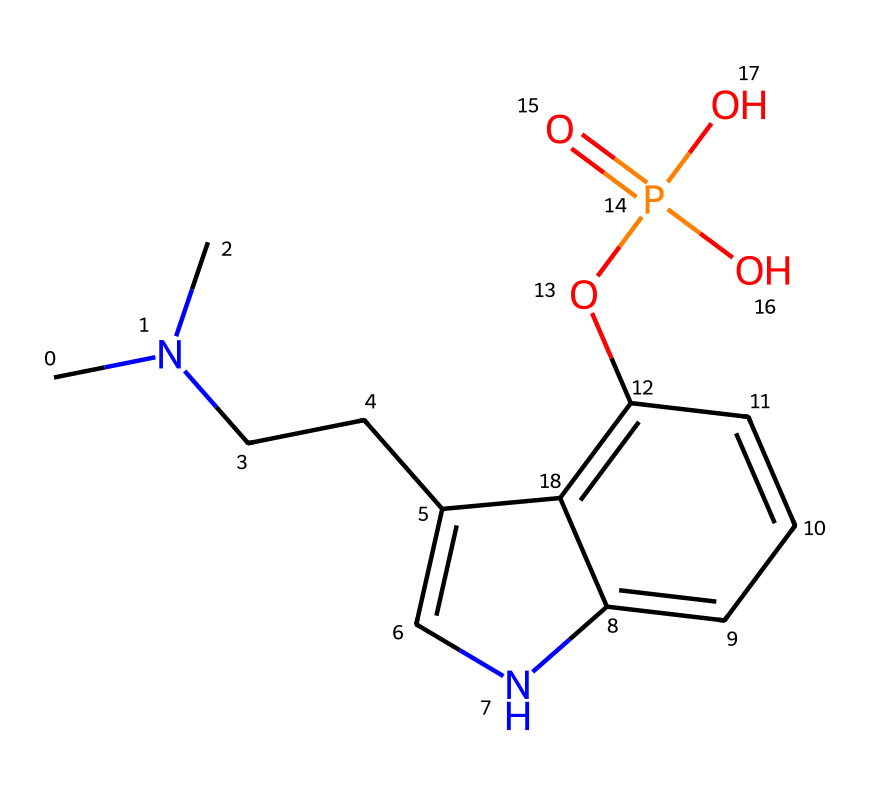What is the main active compound in this structure? The rendered chemical corresponds to psilocybin, which is the active compound in various species of mushrooms known for their psychoactive properties. The chemical structure is recognizable by its specific arrangement of atoms and functional groups.
Answer: psilocybin How many nitrogen atoms are present? By examining the structure, I can identify there are two distinct nitrogen atoms: one is part of a side chain and the other is incorporated within the indole ring system. Counting these yields a total of two nitrogen atoms.
Answer: 2 What functional group is represented by the -OP(=O)(O)O part of this structure? The -OP(=O)(O)O segment indicates a phosphate functional group. This is deduced from the presence of phosphorus (P) with attached oxygen atoms and a specific bonding pattern that defines phosphates.
Answer: phosphate How many total carbon atoms are in this compound? Count the carbon atoms indicated by the 'C' symbols in the structure. The molecule has a total of 12 carbon atoms when numerically assessed from the graphical representation.
Answer: 12 What type of compound is psilocybin classified as? Psilocybin is classified as a tryptamine derivative. This classification is derived from its structural features, primarily the indole ring structure, which is typical of tryptamines, along with the N,N-dimethyl substituents.
Answer: tryptamine How many oxygen atoms are present in this molecule? By analyzing the chemical structure visually, I can count a total of four oxygen atoms. They are present in both the phosphate and the hydroxyl groups within the molecular composition.
Answer: 4 Is this compound likely to be soluble in water? Yes, due to the presence of multiple polar functional groups (such as the phosphate and hydroxyl groups), the compound is likely to exhibit good solubility in water. The hydrophilic nature of these groups enhances this property.
Answer: yes 